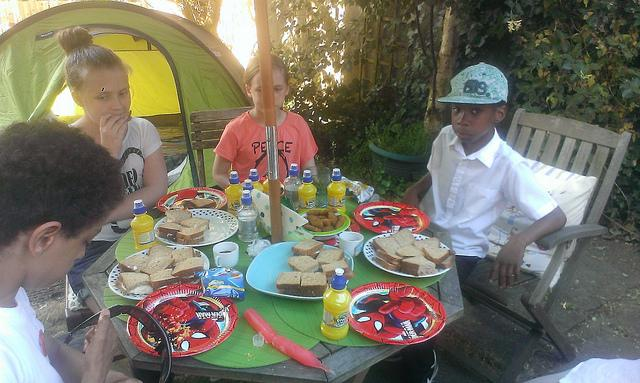What comic brand owns the franchise depicted here?

Choices:
A) pixar
B) dc
C) disney
D) marvel marvel 